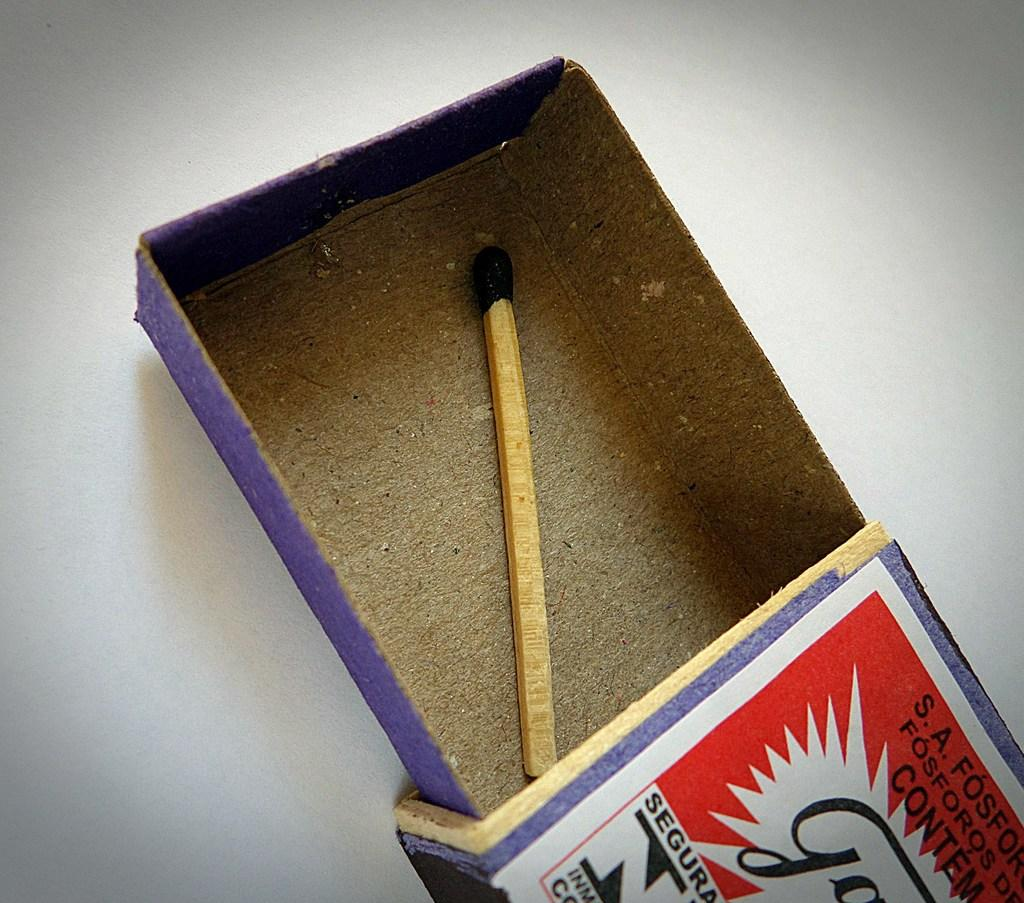<image>
Summarize the visual content of the image. an open match box with a single match for SA Fosfor 